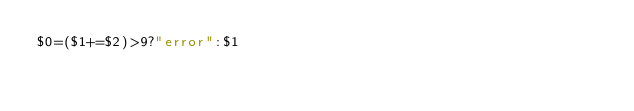Convert code to text. <code><loc_0><loc_0><loc_500><loc_500><_Awk_>$0=($1+=$2)>9?"error":$1</code> 